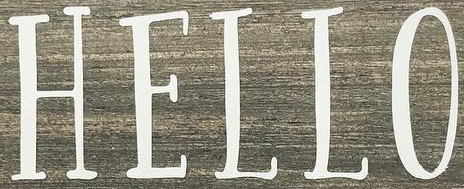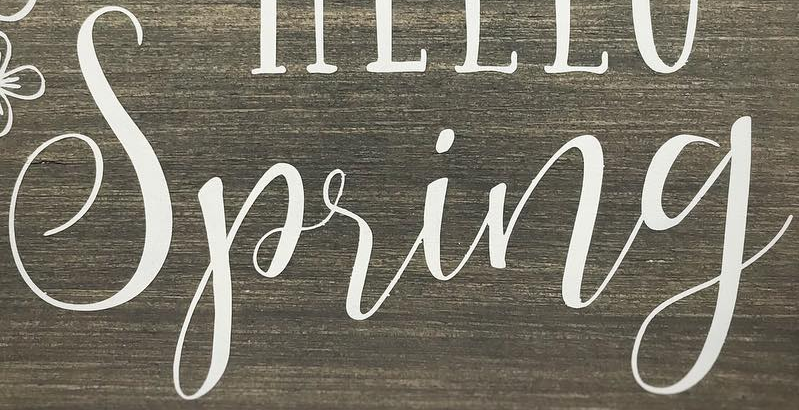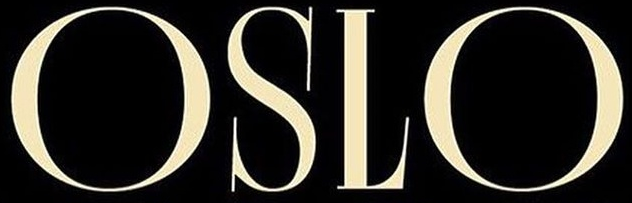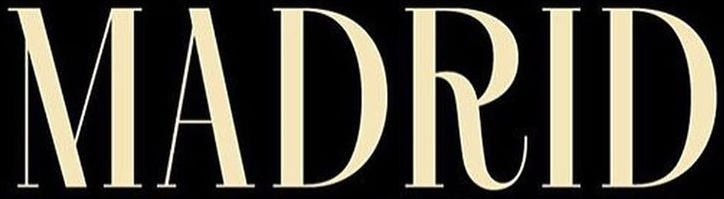What words are shown in these images in order, separated by a semicolon? HELLO; Spring; OSLO; MADRID 